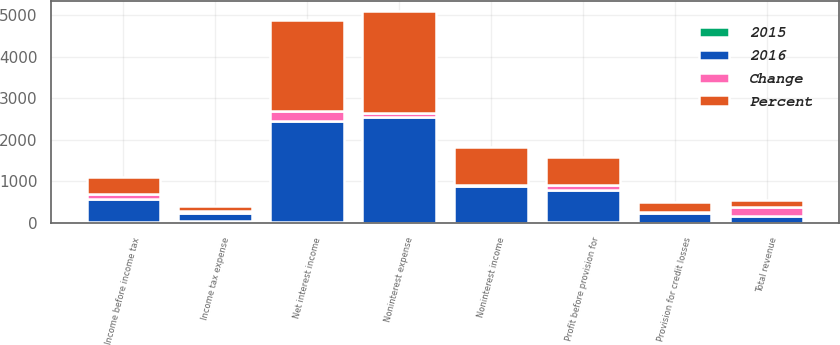<chart> <loc_0><loc_0><loc_500><loc_500><stacked_bar_chart><ecel><fcel>Net interest income<fcel>Noninterest income<fcel>Total revenue<fcel>Noninterest expense<fcel>Profit before provision for<fcel>Provision for credit losses<fcel>Income before income tax<fcel>Income tax expense<nl><fcel>2016<fcel>2443<fcel>883<fcel>164.5<fcel>2547<fcel>779<fcel>243<fcel>536<fcel>191<nl><fcel>Percent<fcel>2198<fcel>910<fcel>164.5<fcel>2456<fcel>652<fcel>252<fcel>400<fcel>138<nl><fcel>Change<fcel>245<fcel>27<fcel>218<fcel>91<fcel>127<fcel>9<fcel>136<fcel>53<nl><fcel>2015<fcel>11<fcel>3<fcel>7<fcel>4<fcel>19<fcel>4<fcel>34<fcel>38<nl></chart> 